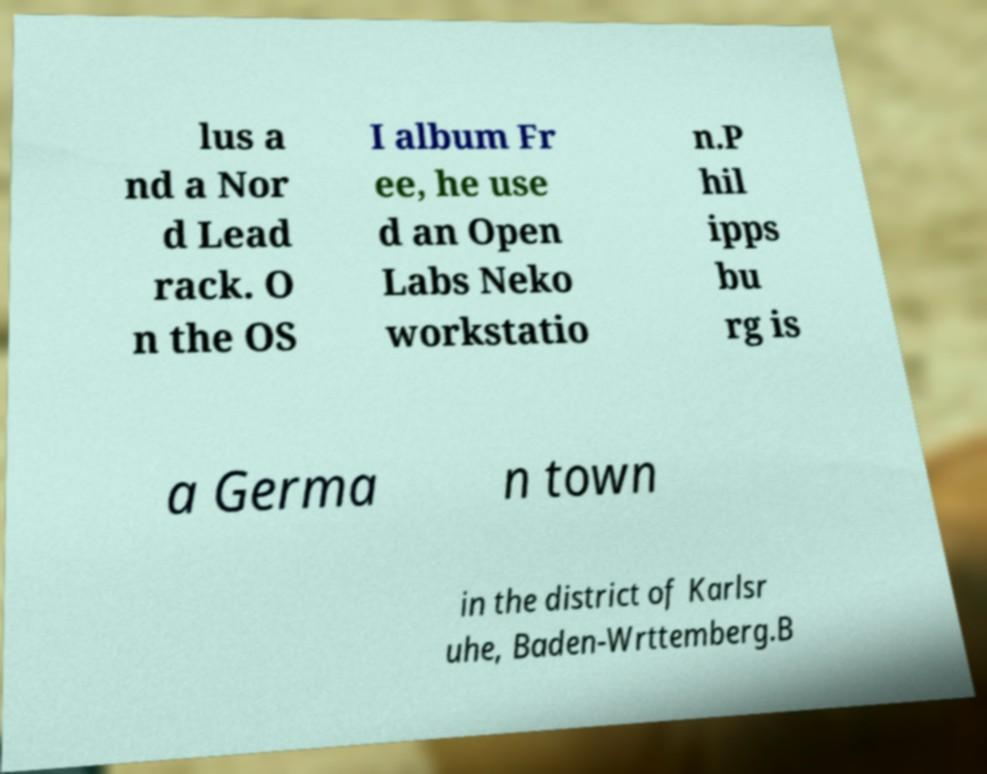Can you read and provide the text displayed in the image?This photo seems to have some interesting text. Can you extract and type it out for me? lus a nd a Nor d Lead rack. O n the OS I album Fr ee, he use d an Open Labs Neko workstatio n.P hil ipps bu rg is a Germa n town in the district of Karlsr uhe, Baden-Wrttemberg.B 